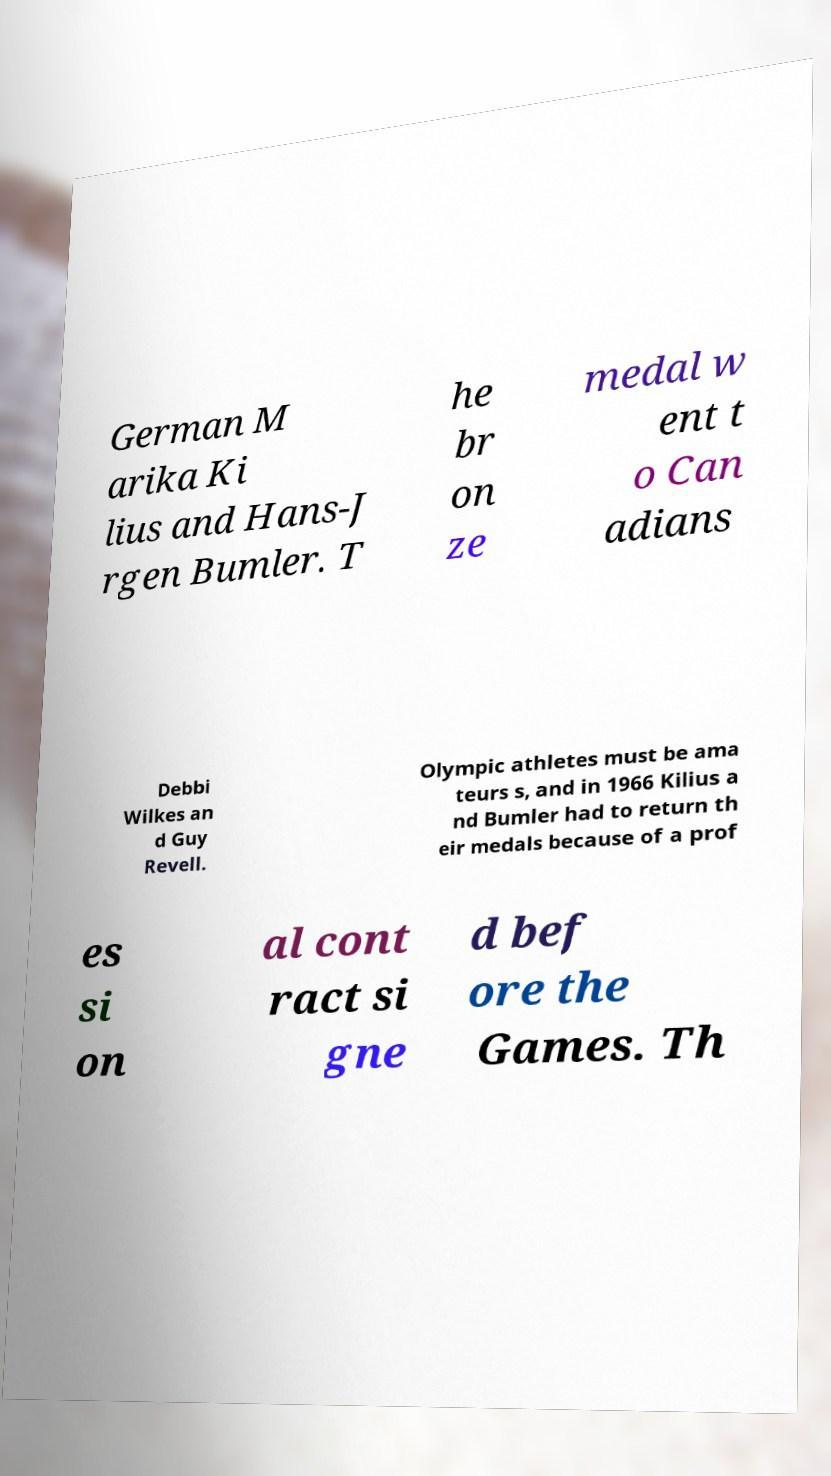Please read and relay the text visible in this image. What does it say? German M arika Ki lius and Hans-J rgen Bumler. T he br on ze medal w ent t o Can adians Debbi Wilkes an d Guy Revell. Olympic athletes must be ama teurs s, and in 1966 Kilius a nd Bumler had to return th eir medals because of a prof es si on al cont ract si gne d bef ore the Games. Th 